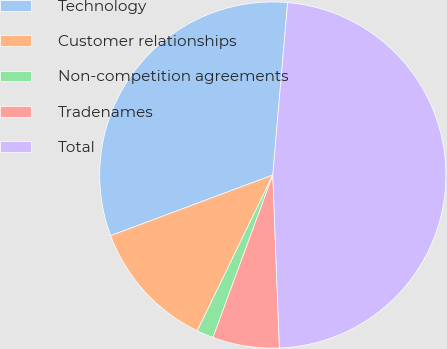Convert chart to OTSL. <chart><loc_0><loc_0><loc_500><loc_500><pie_chart><fcel>Technology<fcel>Customer relationships<fcel>Non-competition agreements<fcel>Tradenames<fcel>Total<nl><fcel>32.06%<fcel>12.12%<fcel>1.57%<fcel>6.22%<fcel>48.03%<nl></chart> 